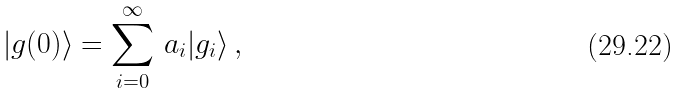<formula> <loc_0><loc_0><loc_500><loc_500>| g ( 0 ) \rangle = \sum _ { i = 0 } ^ { \infty } \, a _ { i } | g _ { i } \rangle \, ,</formula> 